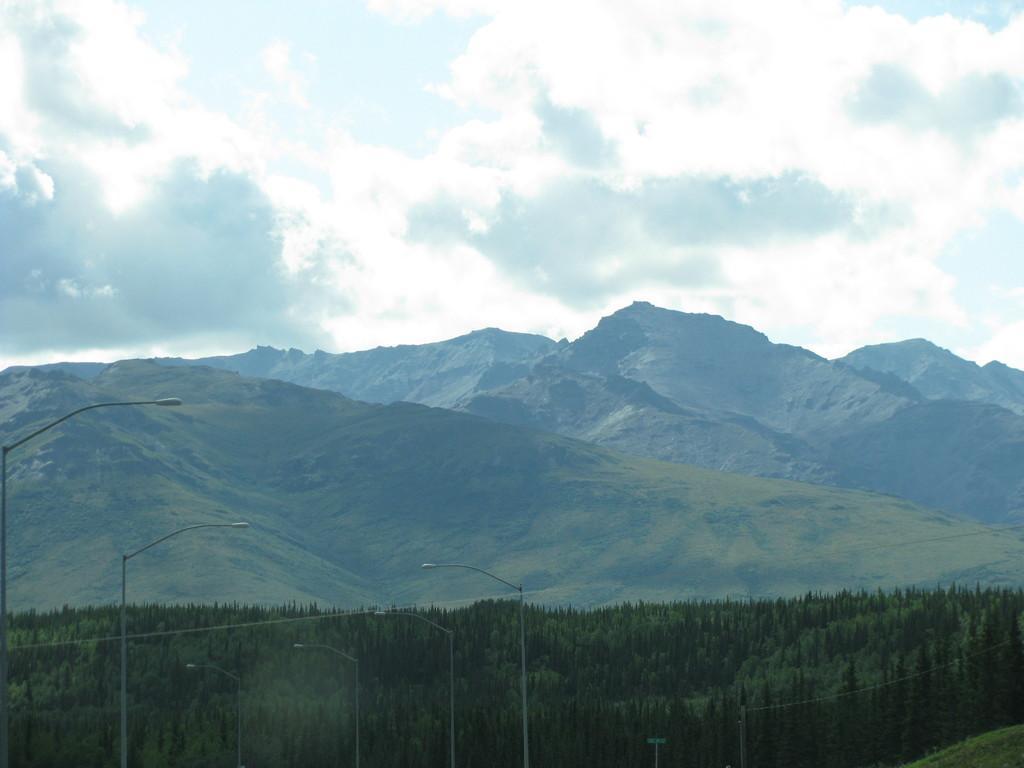Can you describe this image briefly? Here in the image we can see beautiful view of the nature. In the front there are big street poles. Behind there are many trees and in the background there are huge mountains. 